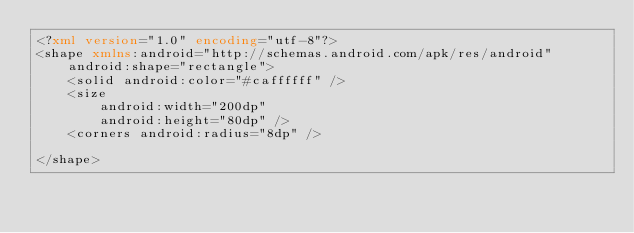<code> <loc_0><loc_0><loc_500><loc_500><_XML_><?xml version="1.0" encoding="utf-8"?>
<shape xmlns:android="http://schemas.android.com/apk/res/android"
    android:shape="rectangle">
    <solid android:color="#caffffff" />
    <size
        android:width="200dp"
        android:height="80dp" />
    <corners android:radius="8dp" />

</shape>
</code> 